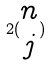<formula> <loc_0><loc_0><loc_500><loc_500>2 ( \begin{matrix} n \\ j \end{matrix} )</formula> 